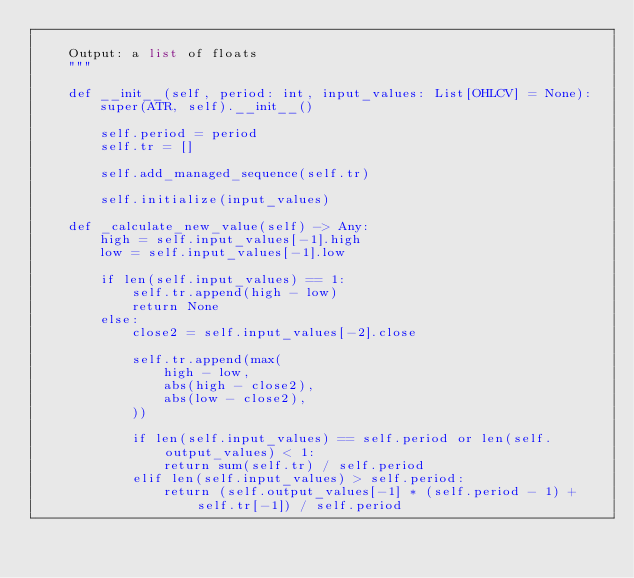<code> <loc_0><loc_0><loc_500><loc_500><_Python_>
    Output: a list of floats
    """

    def __init__(self, period: int, input_values: List[OHLCV] = None):
        super(ATR, self).__init__()

        self.period = period
        self.tr = []

        self.add_managed_sequence(self.tr)

        self.initialize(input_values)

    def _calculate_new_value(self) -> Any:
        high = self.input_values[-1].high
        low = self.input_values[-1].low

        if len(self.input_values) == 1:
            self.tr.append(high - low)
            return None
        else:
            close2 = self.input_values[-2].close

            self.tr.append(max(
                high - low,
                abs(high - close2),
                abs(low - close2),
            ))

            if len(self.input_values) == self.period or len(self.output_values) < 1:
                return sum(self.tr) / self.period
            elif len(self.input_values) > self.period:
                return (self.output_values[-1] * (self.period - 1) + self.tr[-1]) / self.period
</code> 